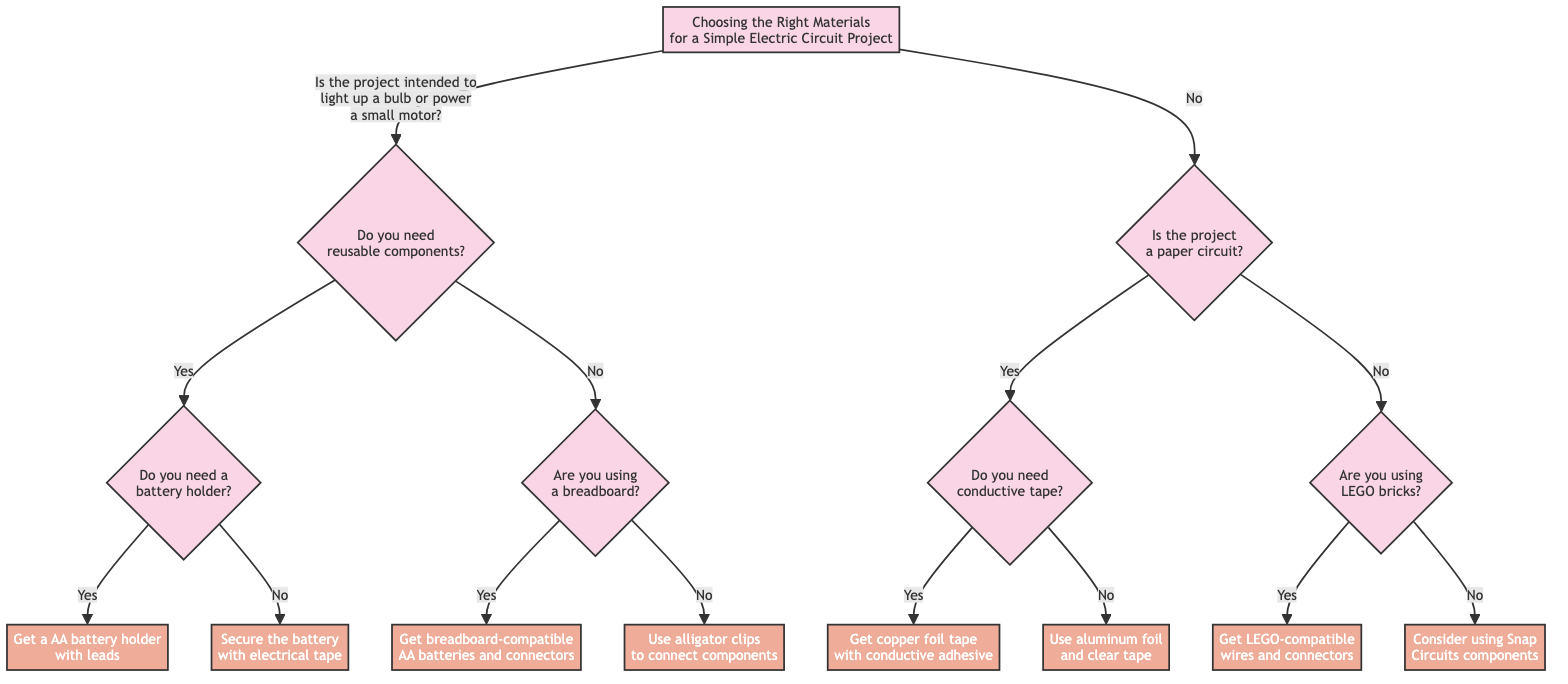What is the root question of the decision tree? The root question of the decision tree is located at the top node labeled "Choosing the Right Materials for a Simple Electric Circuit Project," which asks "Is the project intended to light up a bulb or power a small motor?"
Answer: Is the project intended to light up a bulb or power a small motor? How many possible outcomes are there from the initial decision? From the root question, there are two immediate branches: "Yes" leads to questions about reusable components, and "No" leads to questions about paper circuits. Therefore, there are two possible outcomes from the initial decision.
Answer: 2 What action is taken if the project requires a battery holder? If the project requires a battery holder, you follow the "Yes" path from the "Do you need a battery holder?" question, leading to the action node that states "Get a AA battery holder with leads."
Answer: Get a AA battery holder with leads What are your options if the project is not intended for a bulb or motor? If the project is not intended for a bulb or motor, the decision tree branches to ask if it is a paper circuit or if LEGO bricks are being used. The first branch asks "Is the project a paper circuit?" leading to two other questions and options.
Answer: Is the project a paper circuit? What should you do if the project is a paper circuit and you do not need conductive tape? If the project is a paper circuit and you do not need conductive tape, you will follow the "No" path from the "Do you need conductive tape?" question, resulting in the action "Use aluminum foil and clear tape."
Answer: Use aluminum foil and clear tape What type of wires and connectors should you get if using LEGO bricks? If the project involves using LEGO bricks, the corresponding decision path leads to the action node stating "Get LEGO-compatible wires and connectors."
Answer: Get LEGO-compatible wires and connectors 